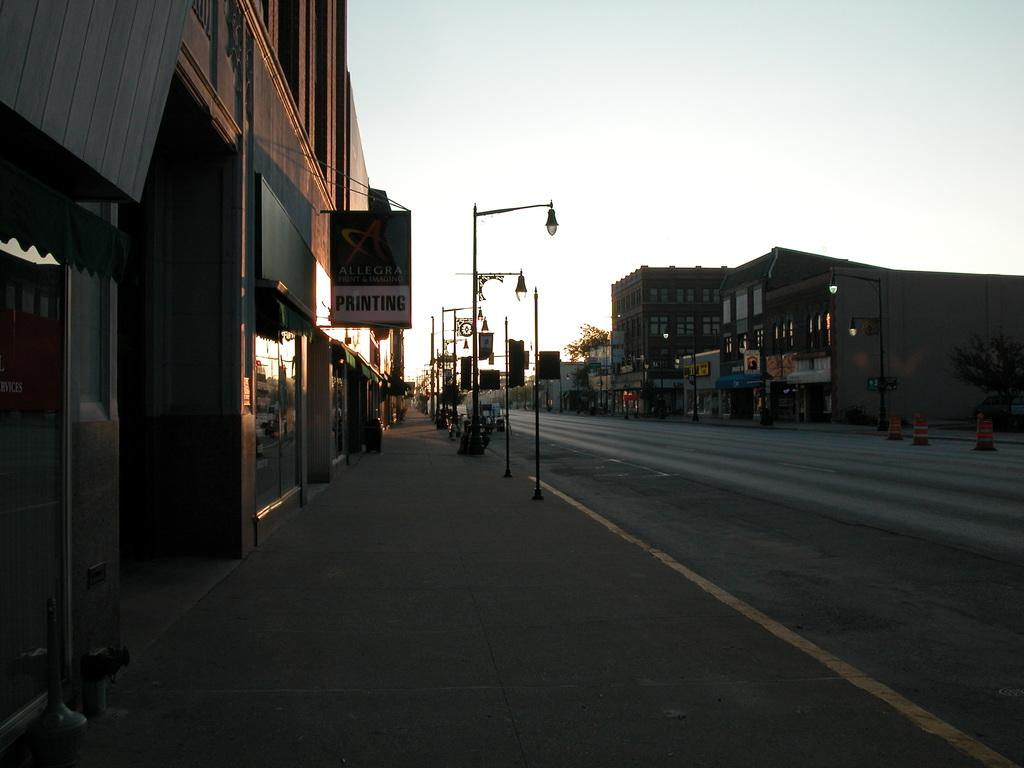What can be seen in the center of the image? The sky is visible in the center of the image. What type of structures are present in the image? There are buildings in the image. What are the poles used for in the image? The poles are likely used for supporting lamps or other objects in the image. Can you describe the lighting in the image? Lamps and lights are visible in the image. What type of signs can be seen in the image? Sign boards are in the image. What other objects can be seen in the image? Traffic poles are in the image, along with a few other objects. Can you tell me how many secretaries are working in the amusement park in the image? There is no amusement park or secretary present in the image. What type of train can be seen passing through the buildings in the image? There is no train visible in the image; it only features buildings, poles, lamps, lights, sign boards, and traffic poles. 